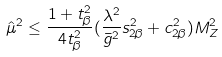<formula> <loc_0><loc_0><loc_500><loc_500>\hat { \mu } ^ { 2 } \leq \frac { 1 + t _ { \beta } ^ { 2 } } { 4 t _ { \beta } ^ { 2 } } ( \frac { \lambda ^ { 2 } } { \bar { g } ^ { 2 } } s _ { 2 \beta } ^ { 2 } + c _ { 2 \beta } ^ { 2 } ) M _ { Z } ^ { 2 }</formula> 